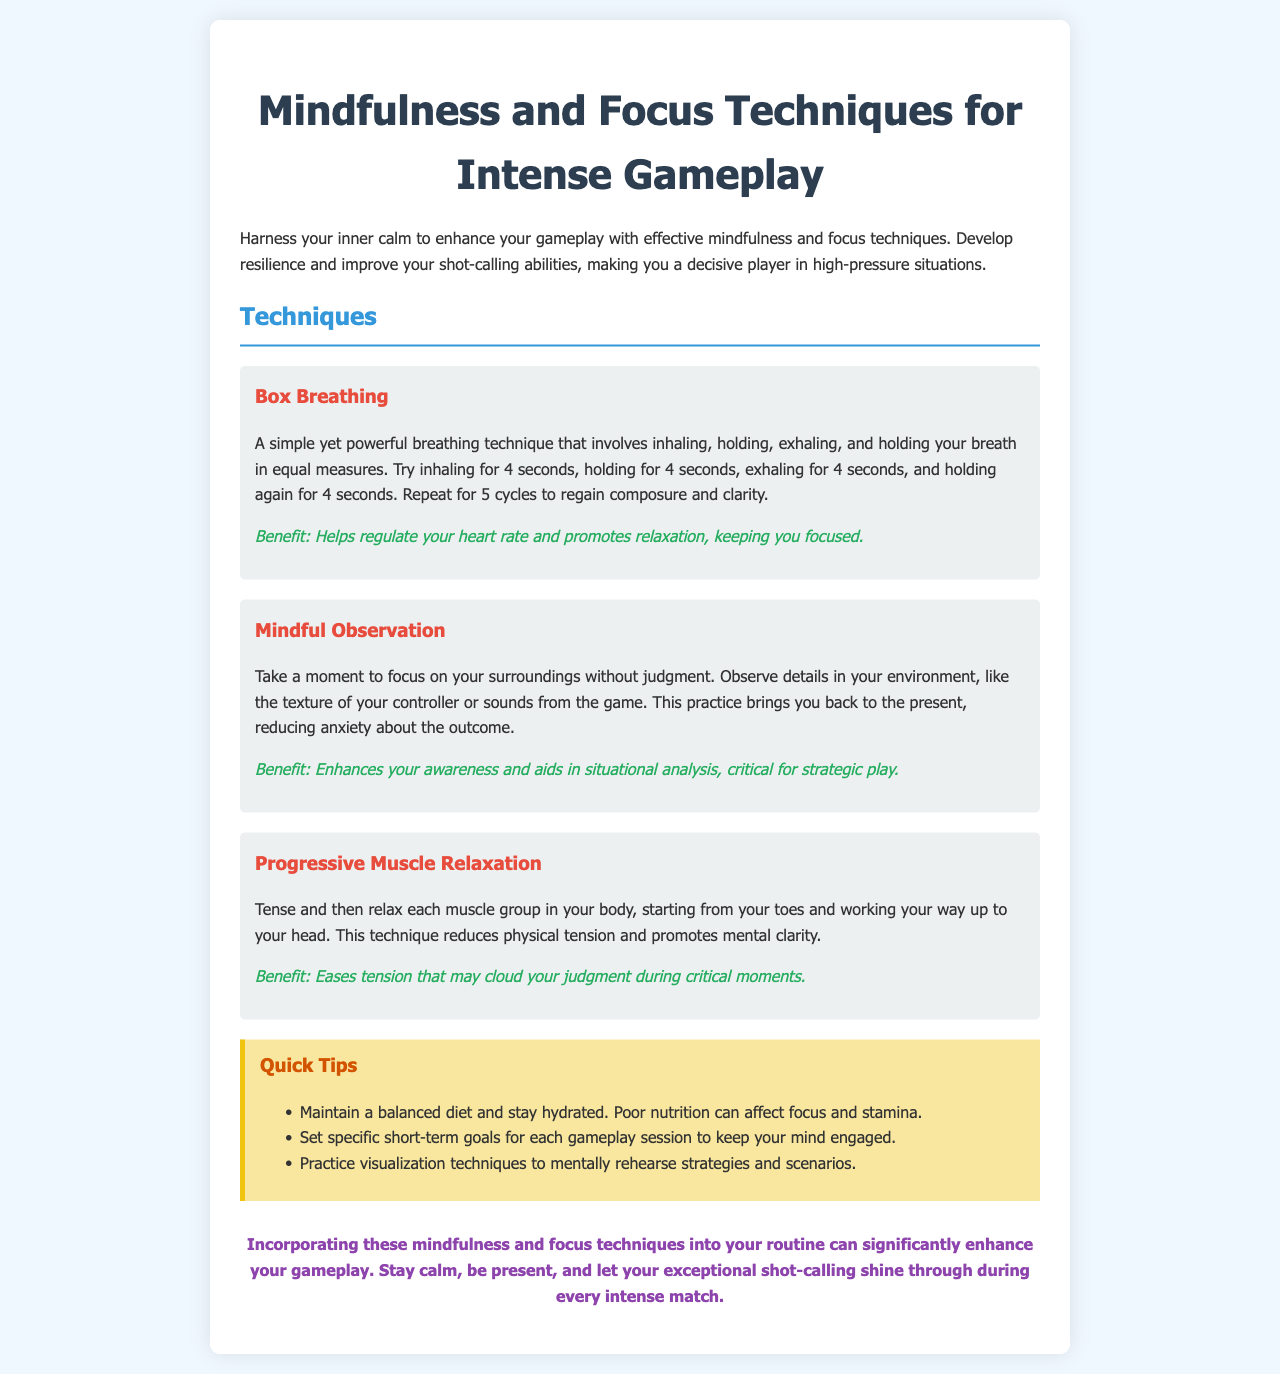What is the title of the brochure? The title is stated prominently at the top of the document.
Answer: Mindfulness and Focus Techniques for Intense Gameplay How many techniques are listed in the document? The document describes three specific techniques for mindfulness and focus.
Answer: 3 What technique uses equal measures of inhaling and exhaling? This is a specific technique mentioned in the techniques section of the brochure.
Answer: Box Breathing What is a benefit of Mindful Observation? Benefits are stated clearly under each technique in the document.
Answer: Enhances your awareness and aids in situational analysis What is one quick tip provided in the brochure? Quick tips are listed in a separate section and highlight essential advice for players.
Answer: Maintain a balanced diet and stay hydrated What is the color associated with the heading in the conclusion? The conclusion section is colored as described in the styling of the document.
Answer: Purple What is the primary focus of this brochure? The introduction outlines the purpose of the document regarding player improvement.
Answer: Mindfulness and focus techniques How long should you hold your breath in the Box Breathing technique? The brochure specifies the duration for each phase of this technique.
Answer: 4 seconds 